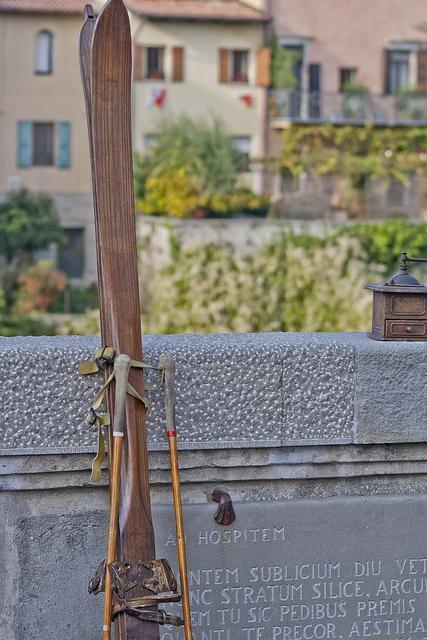How many people are wearing blue jeans?
Give a very brief answer. 0. 